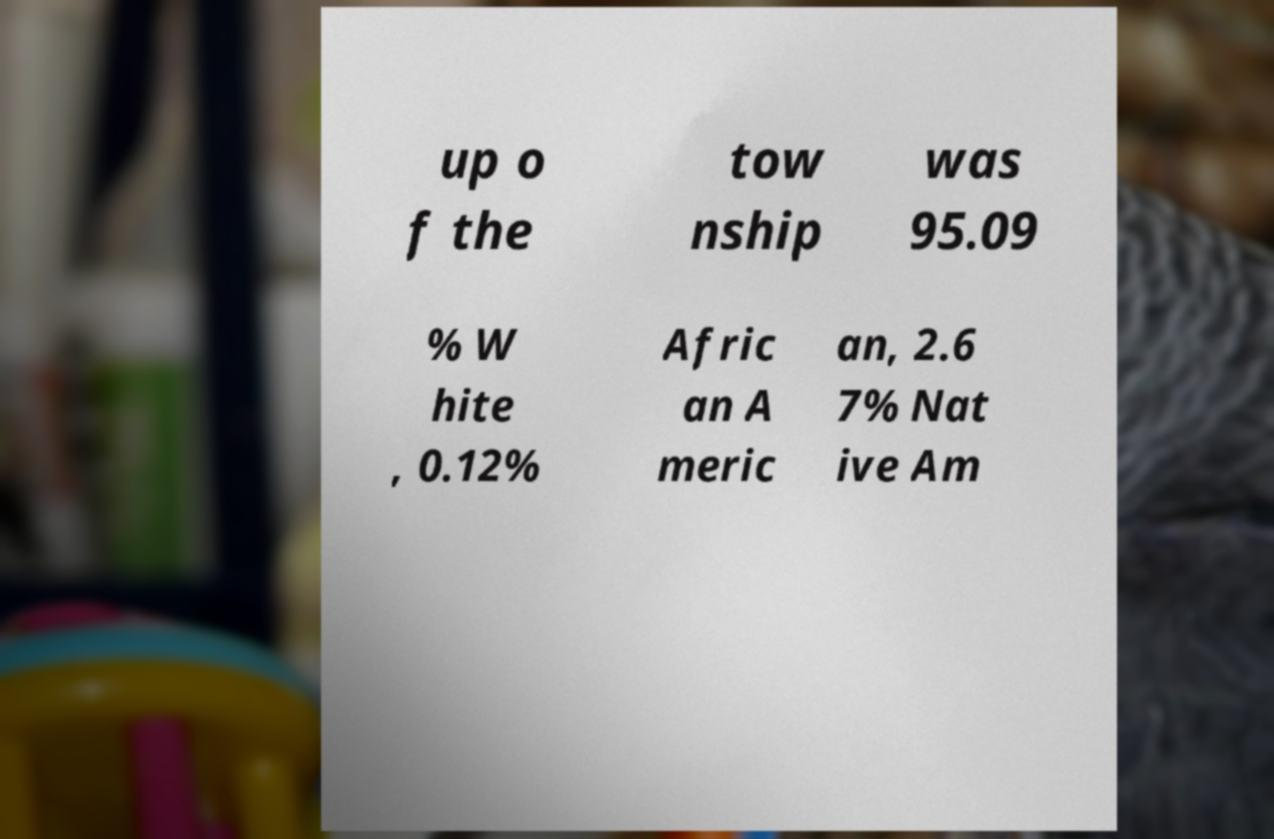Can you read and provide the text displayed in the image?This photo seems to have some interesting text. Can you extract and type it out for me? up o f the tow nship was 95.09 % W hite , 0.12% Afric an A meric an, 2.6 7% Nat ive Am 